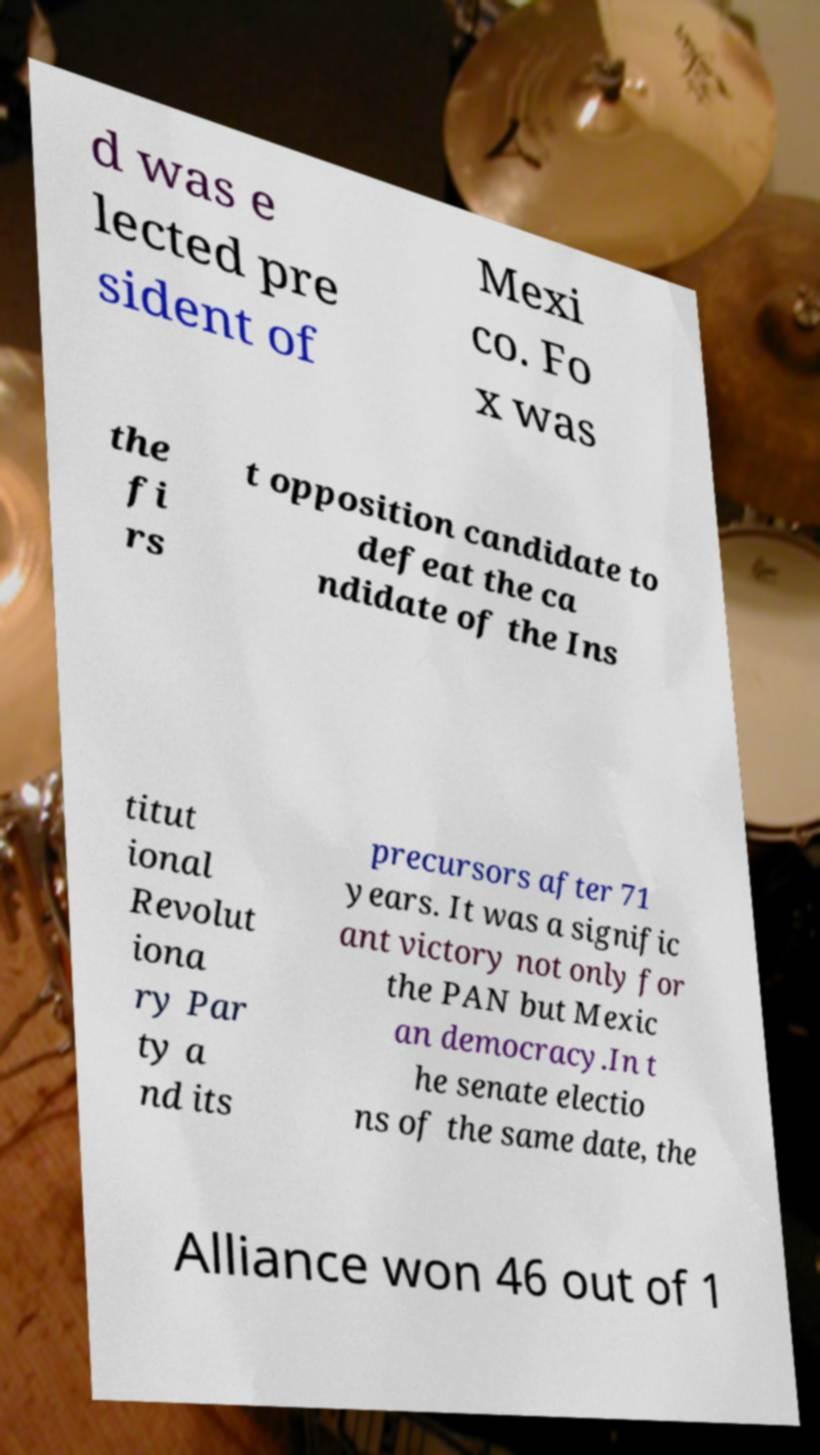For documentation purposes, I need the text within this image transcribed. Could you provide that? d was e lected pre sident of Mexi co. Fo x was the fi rs t opposition candidate to defeat the ca ndidate of the Ins titut ional Revolut iona ry Par ty a nd its precursors after 71 years. It was a signific ant victory not only for the PAN but Mexic an democracy.In t he senate electio ns of the same date, the Alliance won 46 out of 1 